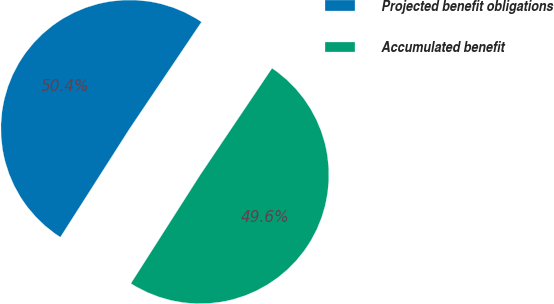Convert chart. <chart><loc_0><loc_0><loc_500><loc_500><pie_chart><fcel>Projected benefit obligations<fcel>Accumulated benefit<nl><fcel>50.39%<fcel>49.61%<nl></chart> 